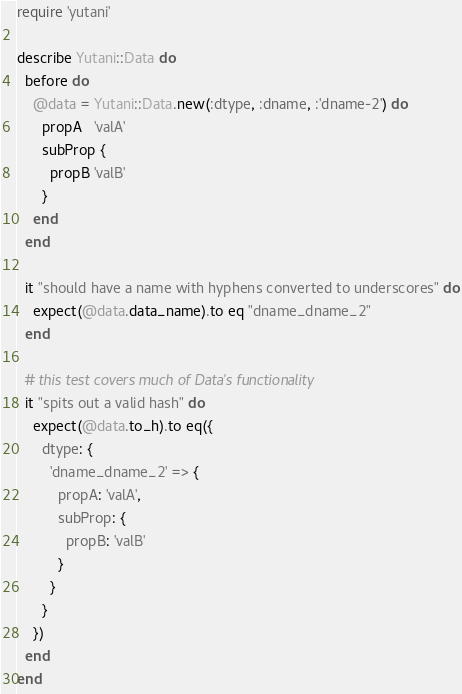<code> <loc_0><loc_0><loc_500><loc_500><_Ruby_>require 'yutani'

describe Yutani::Data do
  before do
    @data = Yutani::Data.new(:dtype, :dname, :'dname-2') do
      propA   'valA'
      subProp {
        propB 'valB'
      }
    end
  end

  it "should have a name with hyphens converted to underscores" do
    expect(@data.data_name).to eq "dname_dname_2"
  end

  # this test covers much of Data's functionality
  it "spits out a valid hash" do
    expect(@data.to_h).to eq({
      dtype: {
        'dname_dname_2' => {
          propA: 'valA',
          subProp: {
            propB: 'valB'
          }
        }
      }
    })
  end
end
</code> 